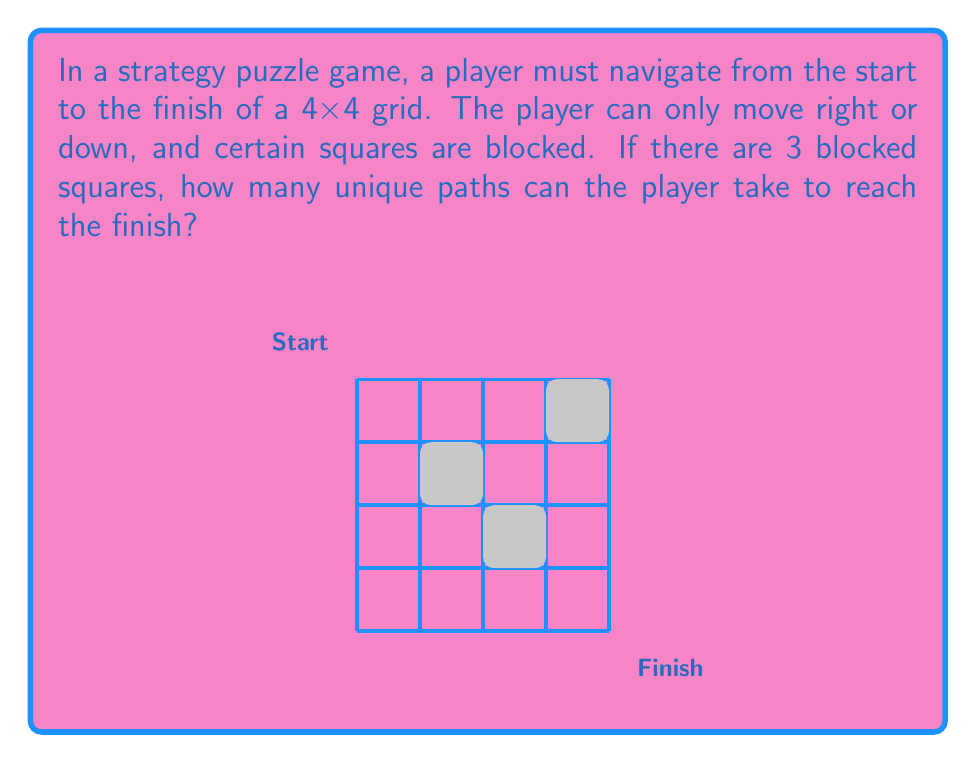Solve this math problem. Let's approach this step-by-step:

1) In a 4x4 grid without blocked squares, the total number of paths would be $\binom{8}{4} = 70$, as the player needs to make 4 right moves and 4 down moves in any order.

2) However, we need to subtract the paths that go through blocked squares. Let's consider each blocked square:

   a) (1,2): Paths through this square = $\binom{3}{1} \times \binom{5}{3} = 30$
   b) (2,1): Paths through this square = $\binom{3}{2} \times \binom{5}{2} = 30$
   c) (3,3): Paths through this square = $\binom{6}{3} \times \binom{2}{1} = 40$

3) However, if we simply subtract these from 70, we'll be subtracting some paths twice. We need to add back the paths that go through two blocked squares:

   a) (1,2) and (3,3): $\binom{3}{1} \times \binom{3}{2} = 9$
   b) (2,1) and (3,3): $\binom{3}{2} \times \binom{3}{1} = 9$

   There are no paths that go through both (1,2) and (2,1), or all three blocked squares.

4) Therefore, the total number of valid paths is:

   $$70 - (30 + 30 + 40) + (9 + 9) = 70 - 100 + 18 = -12$$

5) But we can't have a negative number of paths. This means we've overcounted the blocked paths. The reason is that some of the paths we calculated as going through blocked squares weren't valid to begin with (they went off the grid).

6) The actual number of valid paths is:

   Right-Down sequences: $\binom{8}{4} = 70$
   Minus paths through (1,2): $\binom{3}{1} \times \binom{5}{3} = 30$
   Minus paths through (2,1): $\binom{3}{2} \times \binom{5}{2} = 30$
   Minus paths through (3,3): $\binom{6}{3} \times \binom{2}{1} = 40$
   Plus paths through (1,2) and (3,3): $\binom{3}{1} \times \binom{3}{2} = 9$
   Plus paths through (2,1) and (3,3): $\binom{3}{2} \times \binom{3}{1} = 9$

   $$70 - 30 - 30 - 40 + 9 + 9 = -12$$

7) The discrepancy comes from the fact that some of these paths aren't actually possible on the 4x4 grid. We need to adjust our calculations:

   Paths through (1,2): $\binom{3}{1} \times \binom{3}{3} = 3$
   Paths through (2,1): $\binom{3}{2} \times \binom{3}{2} = 9$
   Paths through (3,3): $\binom{6}{3} \times \binom{1}{1} = 20$

8) Now, the correct calculation is:

   $$70 - 3 - 9 - 20 = 38$$

Thus, there are 38 unique valid paths from start to finish.
Answer: 38 